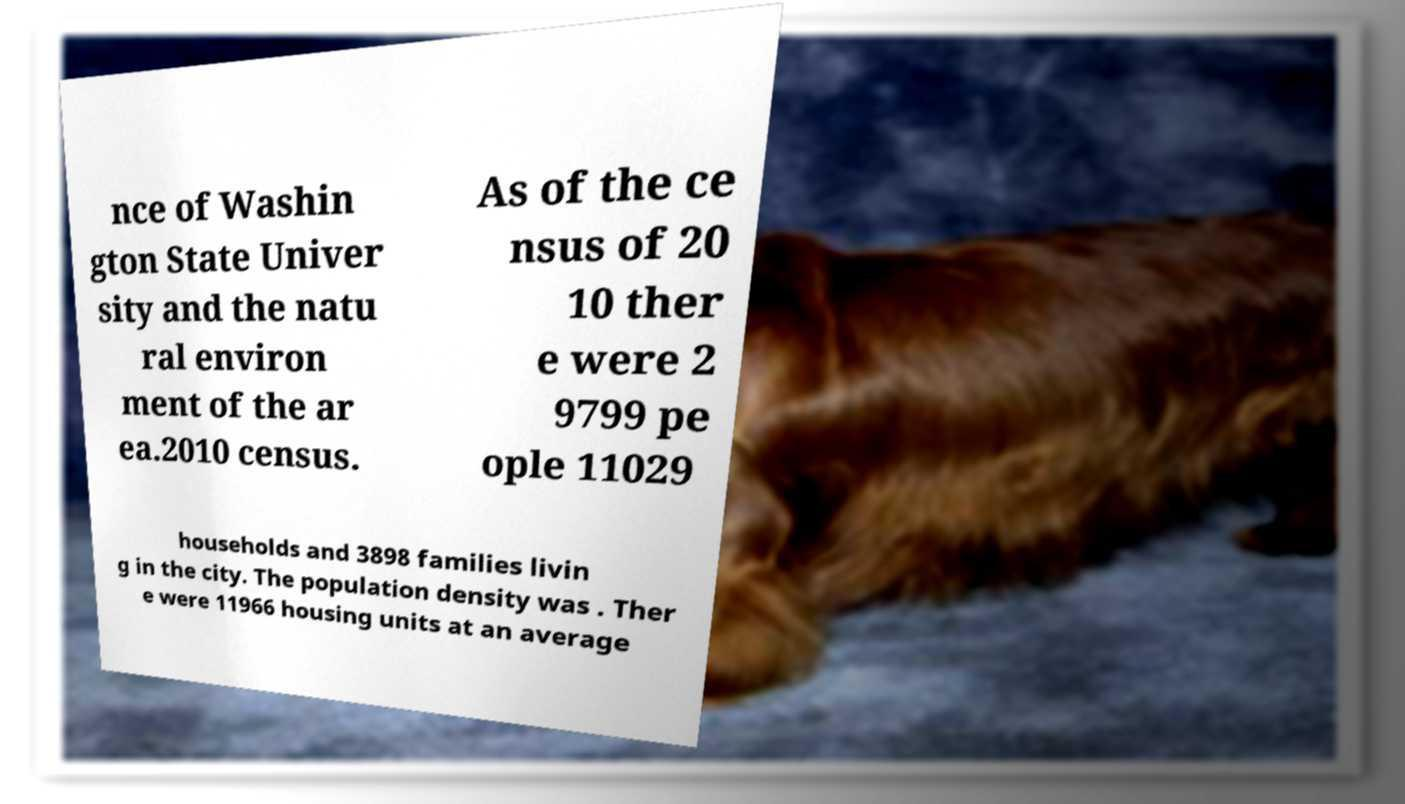Please read and relay the text visible in this image. What does it say? nce of Washin gton State Univer sity and the natu ral environ ment of the ar ea.2010 census. As of the ce nsus of 20 10 ther e were 2 9799 pe ople 11029 households and 3898 families livin g in the city. The population density was . Ther e were 11966 housing units at an average 